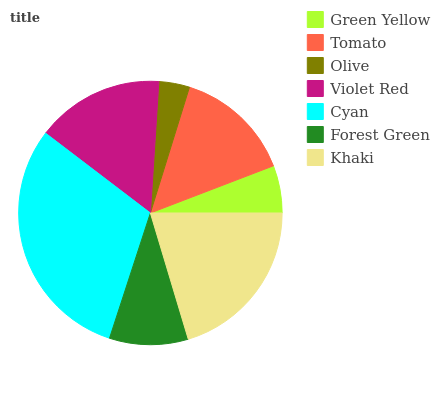Is Olive the minimum?
Answer yes or no. Yes. Is Cyan the maximum?
Answer yes or no. Yes. Is Tomato the minimum?
Answer yes or no. No. Is Tomato the maximum?
Answer yes or no. No. Is Tomato greater than Green Yellow?
Answer yes or no. Yes. Is Green Yellow less than Tomato?
Answer yes or no. Yes. Is Green Yellow greater than Tomato?
Answer yes or no. No. Is Tomato less than Green Yellow?
Answer yes or no. No. Is Tomato the high median?
Answer yes or no. Yes. Is Tomato the low median?
Answer yes or no. Yes. Is Violet Red the high median?
Answer yes or no. No. Is Green Yellow the low median?
Answer yes or no. No. 